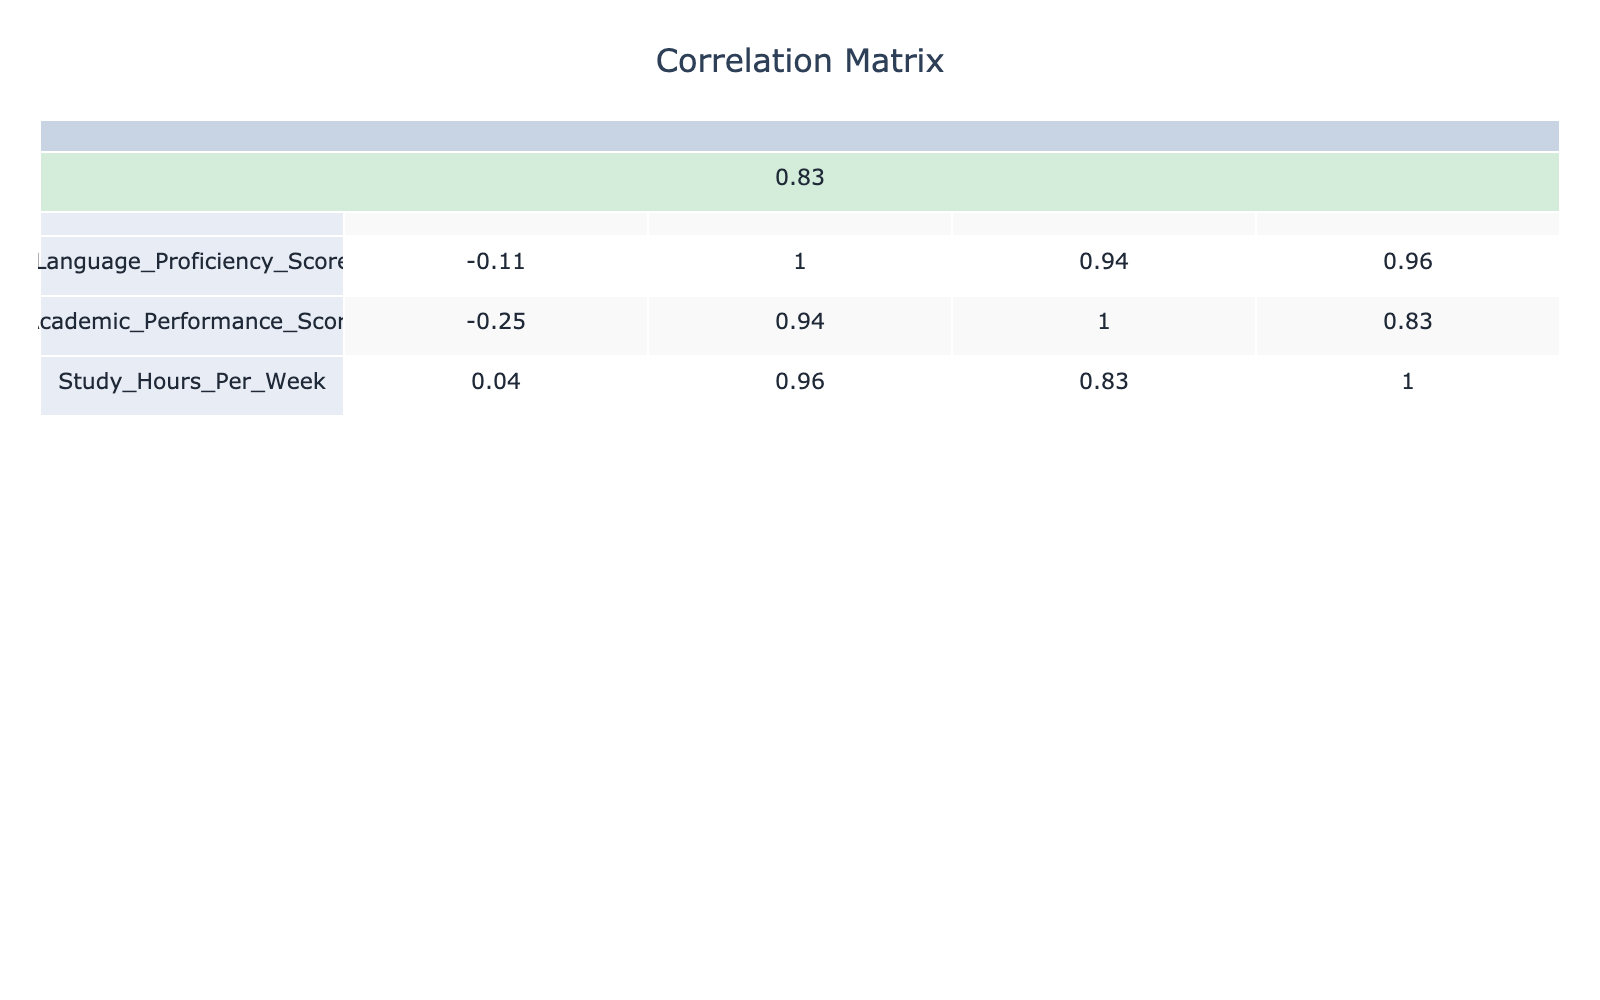What is the correlation between Language Proficiency Score and Academic Performance Score? The table shows the correlation value between Language Proficiency Score and Academic Performance Score is approximately 0.84. This strong positive correlation indicates that as language proficiency increases, academic performance also tends to increase.
Answer: 0.84 Which student has the highest Language Proficiency Score? From the table, Student 3 has the highest Language Proficiency Score of 90.
Answer: Student 3 Is there a negative correlation between Study Hours per Week and Academic Performance Score? The correlation value is approximately 0.27, which is positive, indicating that there is no negative correlation between Study Hours per Week and Academic Performance Score.
Answer: No What is the average Academic Performance Score for students from South Korea and China? The Academic Performance Scores for South Korea and China are 90 and 92, respectively. The average is calculated as (90 + 92) / 2 = 91.
Answer: 91 How many students have a Language Proficiency Score above 80? There are 6 students with Language Proficiency Scores above 80: Students 1, 3, 5, 7, 8, and 10.
Answer: 6 Based on the table, which country of origin has the lowest average Academic Performance Score? The average for Brazil, with a score of 75, is the lowest compared to the others. The scores for each country, calculated, confirm this: Brazil (75), South Korea (90), China (92), etc.
Answer: Brazil 